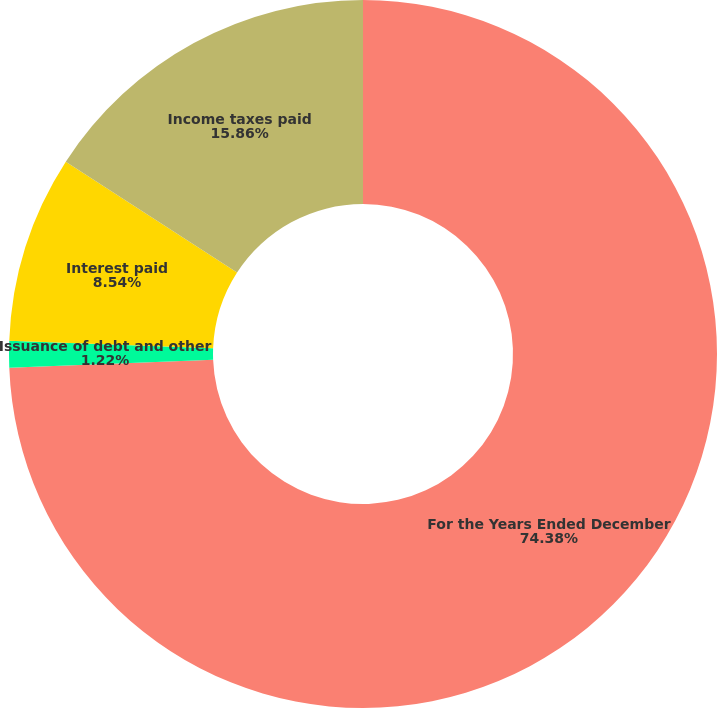Convert chart. <chart><loc_0><loc_0><loc_500><loc_500><pie_chart><fcel>For the Years Ended December<fcel>Issuance of debt and other<fcel>Interest paid<fcel>Income taxes paid<nl><fcel>74.38%<fcel>1.22%<fcel>8.54%<fcel>15.86%<nl></chart> 